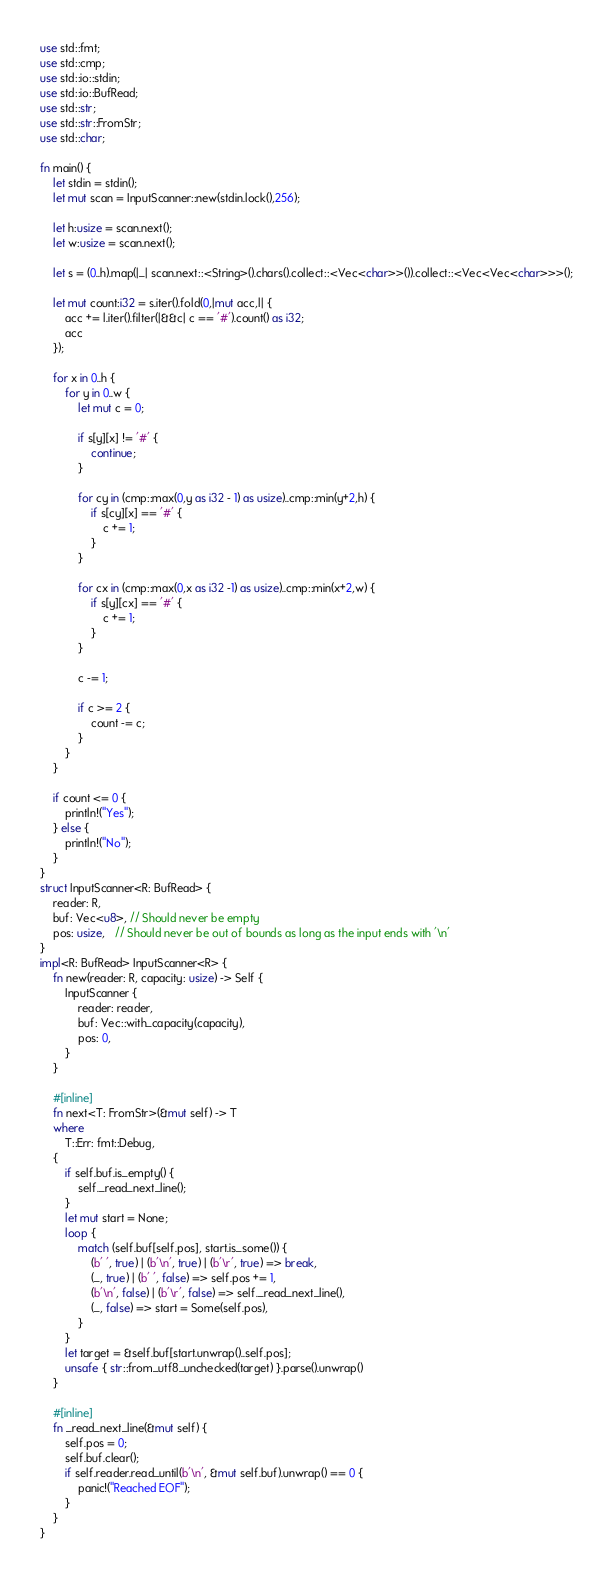Convert code to text. <code><loc_0><loc_0><loc_500><loc_500><_Rust_>use std::fmt;
use std::cmp;
use std::io::stdin;
use std::io::BufRead;
use std::str;
use std::str::FromStr;
use std::char;

fn main() {
	let stdin = stdin();
	let mut scan = InputScanner::new(stdin.lock(),256);

	let h:usize = scan.next();
	let w:usize = scan.next();

	let s = (0..h).map(|_| scan.next::<String>().chars().collect::<Vec<char>>()).collect::<Vec<Vec<char>>>();

	let mut count:i32 = s.iter().fold(0,|mut acc,l| {
		acc += l.iter().filter(|&&c| c == '#').count() as i32;
		acc
	});

	for x in 0..h {
		for y in 0..w {
			let mut c = 0;

			if s[y][x] != '#' {
				continue;
			}

			for cy in (cmp::max(0,y as i32 - 1) as usize)..cmp::min(y+2,h) {
				if s[cy][x] == '#' {
					c += 1;
				}
			}

			for cx in (cmp::max(0,x as i32 -1) as usize)..cmp::min(x+2,w) {
				if s[y][cx] == '#' {
					c += 1;
				}
			}

			c -= 1;

			if c >= 2 {
				count -= c;
			}
		}
	}

	if count <= 0 {
		println!("Yes");
	} else {
		println!("No");
	}
}
struct InputScanner<R: BufRead> {
	reader: R,
	buf: Vec<u8>, // Should never be empty
	pos: usize,   // Should never be out of bounds as long as the input ends with '\n'
}
impl<R: BufRead> InputScanner<R> {
	fn new(reader: R, capacity: usize) -> Self {
		InputScanner {
			reader: reader,
			buf: Vec::with_capacity(capacity),
			pos: 0,
		}
	}

	#[inline]
	fn next<T: FromStr>(&mut self) -> T
	where
		T::Err: fmt::Debug,
	{
		if self.buf.is_empty() {
			self._read_next_line();
		}
		let mut start = None;
		loop {
			match (self.buf[self.pos], start.is_some()) {
				(b' ', true) | (b'\n', true) | (b'\r', true) => break,
				(_, true) | (b' ', false) => self.pos += 1,
				(b'\n', false) | (b'\r', false) => self._read_next_line(),
				(_, false) => start = Some(self.pos),
			}
		}
		let target = &self.buf[start.unwrap()..self.pos];
		unsafe { str::from_utf8_unchecked(target) }.parse().unwrap()
	}

	#[inline]
	fn _read_next_line(&mut self) {
		self.pos = 0;
		self.buf.clear();
		if self.reader.read_until(b'\n', &mut self.buf).unwrap() == 0 {
			panic!("Reached EOF");
		}
	}
}
</code> 